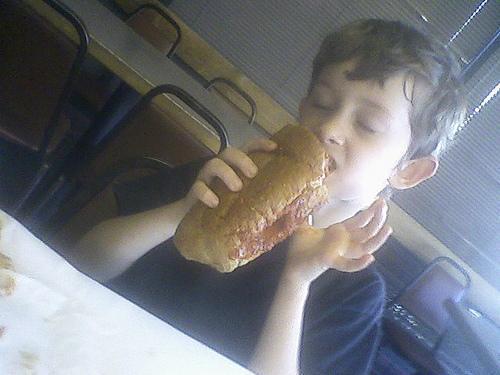How many chairs are there?
Give a very brief answer. 3. How many dining tables are there?
Give a very brief answer. 2. How many kites are there?
Give a very brief answer. 0. 